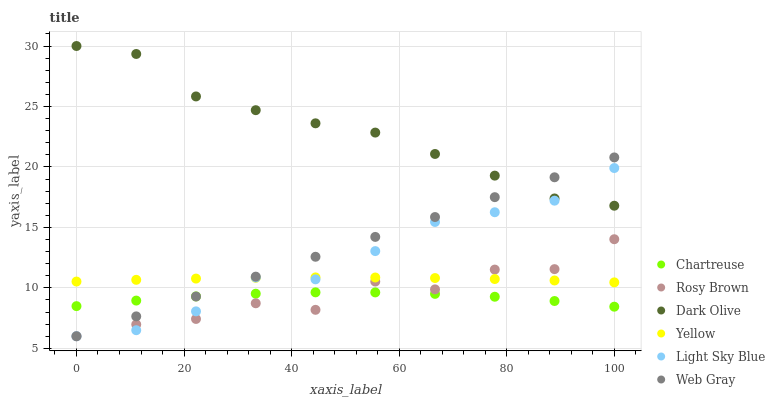Does Chartreuse have the minimum area under the curve?
Answer yes or no. Yes. Does Dark Olive have the maximum area under the curve?
Answer yes or no. Yes. Does Yellow have the minimum area under the curve?
Answer yes or no. No. Does Yellow have the maximum area under the curve?
Answer yes or no. No. Is Web Gray the smoothest?
Answer yes or no. Yes. Is Rosy Brown the roughest?
Answer yes or no. Yes. Is Dark Olive the smoothest?
Answer yes or no. No. Is Dark Olive the roughest?
Answer yes or no. No. Does Rosy Brown have the lowest value?
Answer yes or no. Yes. Does Yellow have the lowest value?
Answer yes or no. No. Does Dark Olive have the highest value?
Answer yes or no. Yes. Does Yellow have the highest value?
Answer yes or no. No. Is Chartreuse less than Yellow?
Answer yes or no. Yes. Is Yellow greater than Chartreuse?
Answer yes or no. Yes. Does Web Gray intersect Light Sky Blue?
Answer yes or no. Yes. Is Web Gray less than Light Sky Blue?
Answer yes or no. No. Is Web Gray greater than Light Sky Blue?
Answer yes or no. No. Does Chartreuse intersect Yellow?
Answer yes or no. No. 